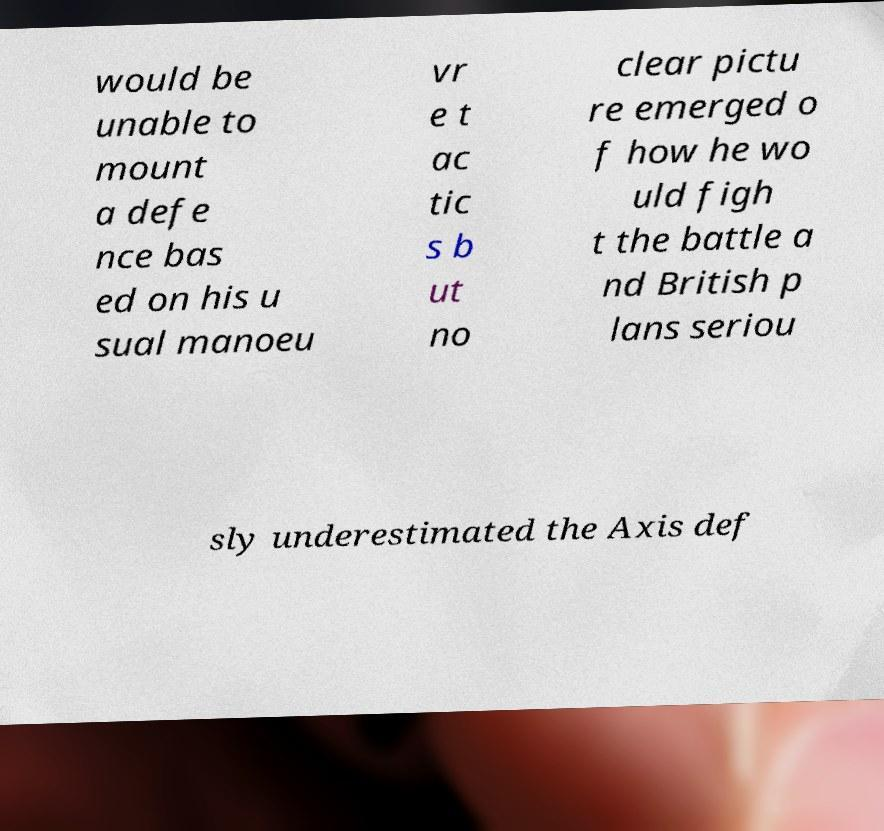Please read and relay the text visible in this image. What does it say? would be unable to mount a defe nce bas ed on his u sual manoeu vr e t ac tic s b ut no clear pictu re emerged o f how he wo uld figh t the battle a nd British p lans seriou sly underestimated the Axis def 